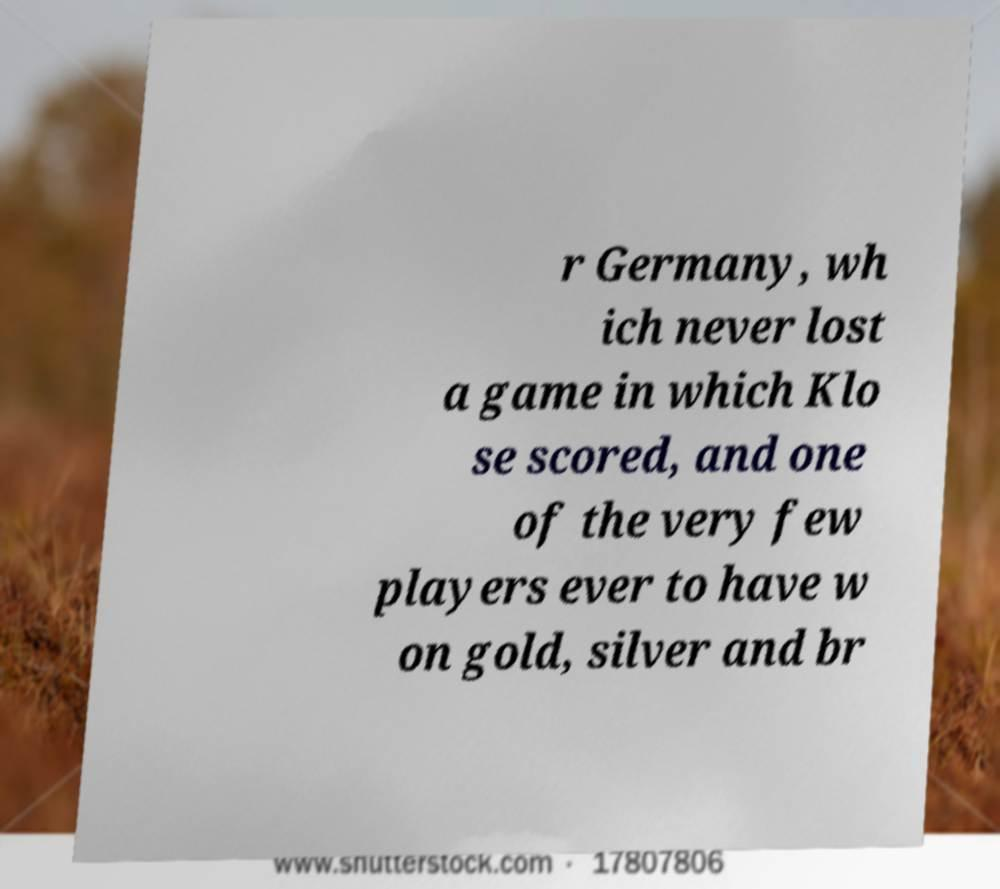There's text embedded in this image that I need extracted. Can you transcribe it verbatim? r Germany, wh ich never lost a game in which Klo se scored, and one of the very few players ever to have w on gold, silver and br 